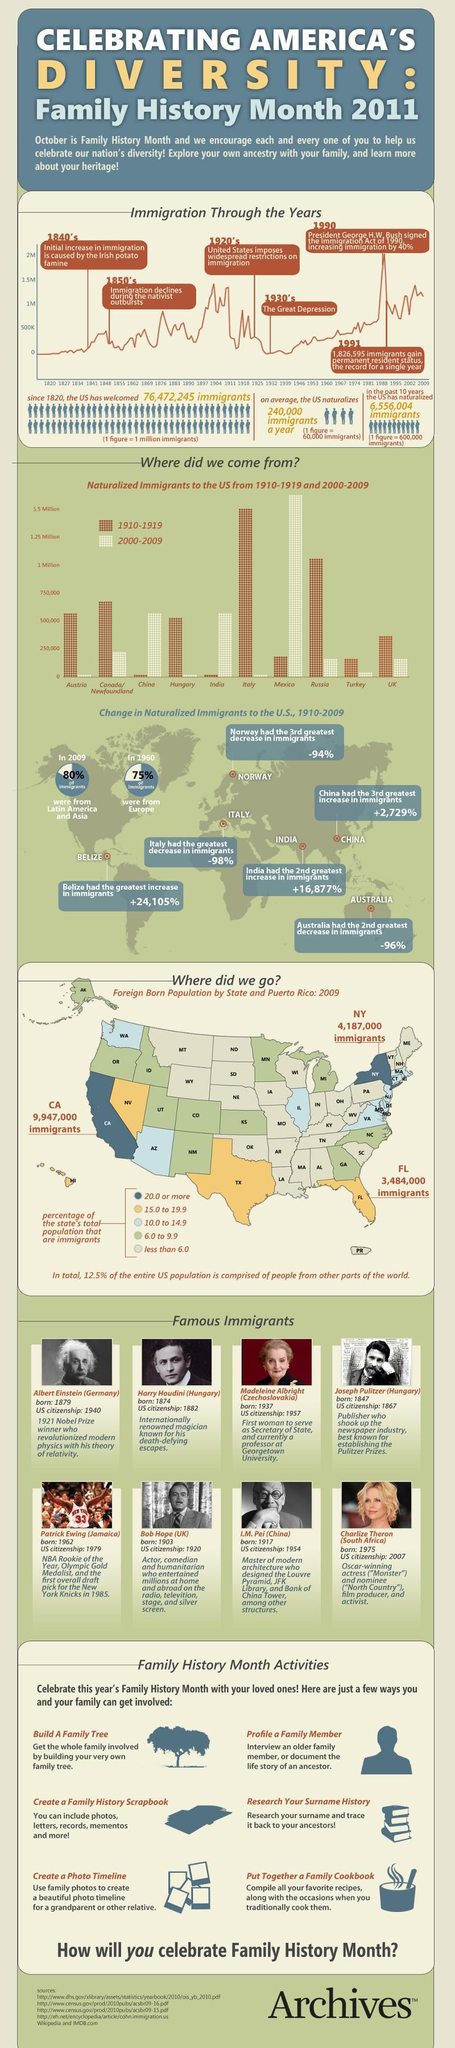Which color signifies that the immigrant percentage of of a state is between 10 and 14.9 yellow, green and light blue?
Answer the question with a short phrase. Light blue When was the Great Depression? 1930's Which year was the immigration increased by 40%? 1990 How many states are marked in yellow ? 3 Which year recorded the highest number of immigrants gaining the PR status? 1991 Who is the famous scientist listed in the immigrant list? Albert Einstein How many countries do the naturalized immigrants in the US belong to ? 10 How many prominent women are listed in the famous immigrants list? 2 Who is the famous sports personality listed in the immigrants list ? Patrick Ewing 